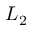Convert formula to latex. <formula><loc_0><loc_0><loc_500><loc_500>L _ { 2 }</formula> 